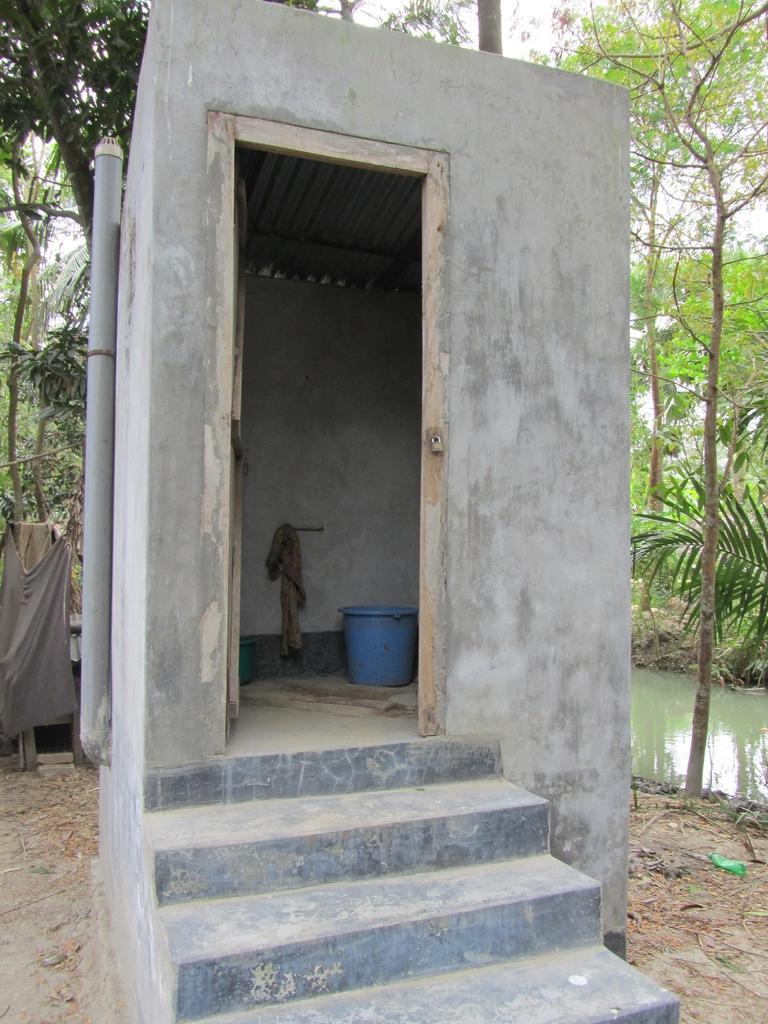Describe this image in one or two sentences. In this image there is a bathroom, there is a bucket, there is a wall, there are stairs truncated towards the bottom of the image, there is a pipe, there is a cloth truncated towards the left of the image, there are trees truncated towards the left of the image, there are trees truncated towards the top of the image, there is water truncated towards the bottom of the image, there are trees truncated towards the right of the image. 